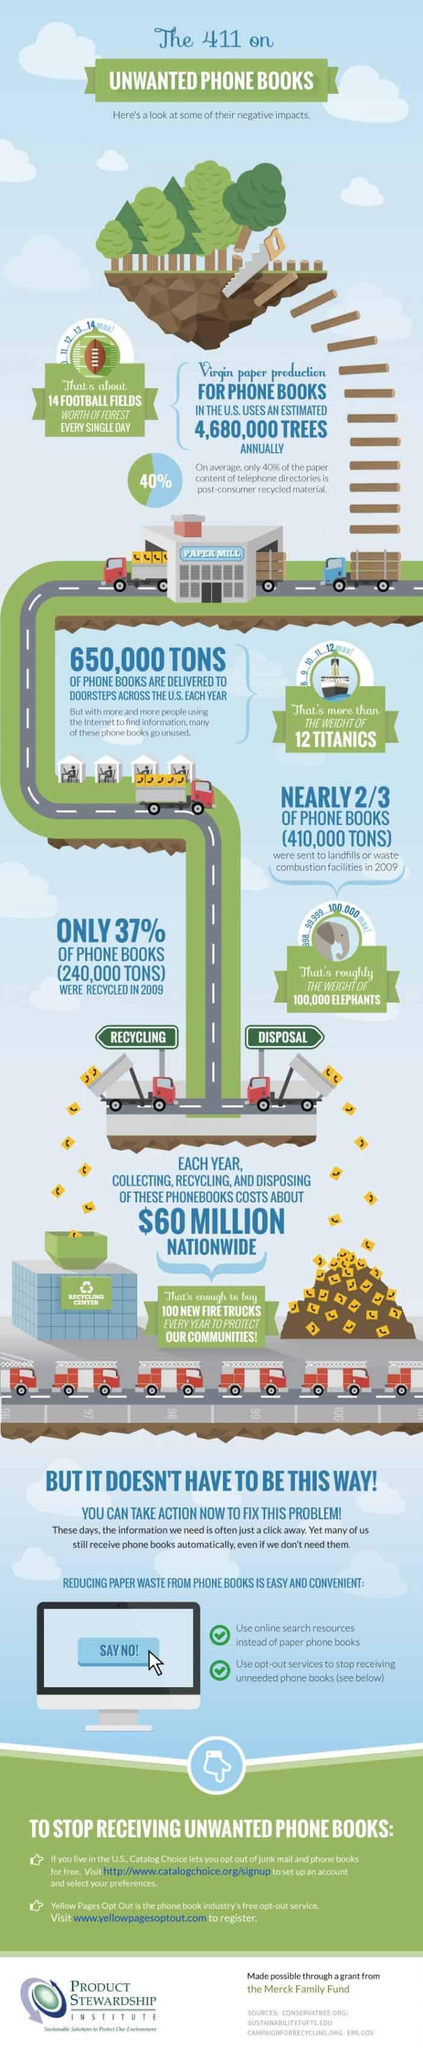What is the comparison made for the weight of phone books sent to landfills in 2009?
Answer the question with a short phrase. the weight of 100,000 elephants To what is the weight of phone books delivered across the US each year compared to? the weight of 12 Titanics What percent of paper in telephone directories is not made of recycled material? 60% 